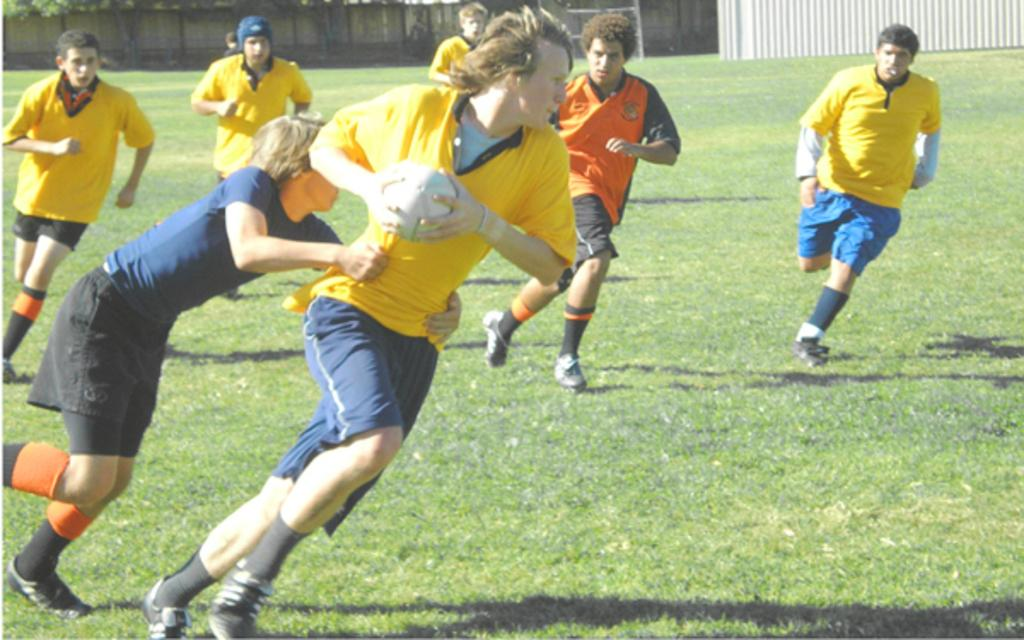What are the people in the image doing? The people in the image are running. What is the man in the center holding? The man in the center is holding a ball. What type of surface is visible at the bottom of the image? There is grass at the bottom of the image. What can be seen in the background of the image? There is a fence in the background of the image. What type of sock is the man wearing on his left foot in the image? There is no information about the man's socks in the image, so we cannot determine the type of sock he is wearing. What type of polish is being applied to the fence in the background? There is no indication of any polish being applied to the fence in the image. 